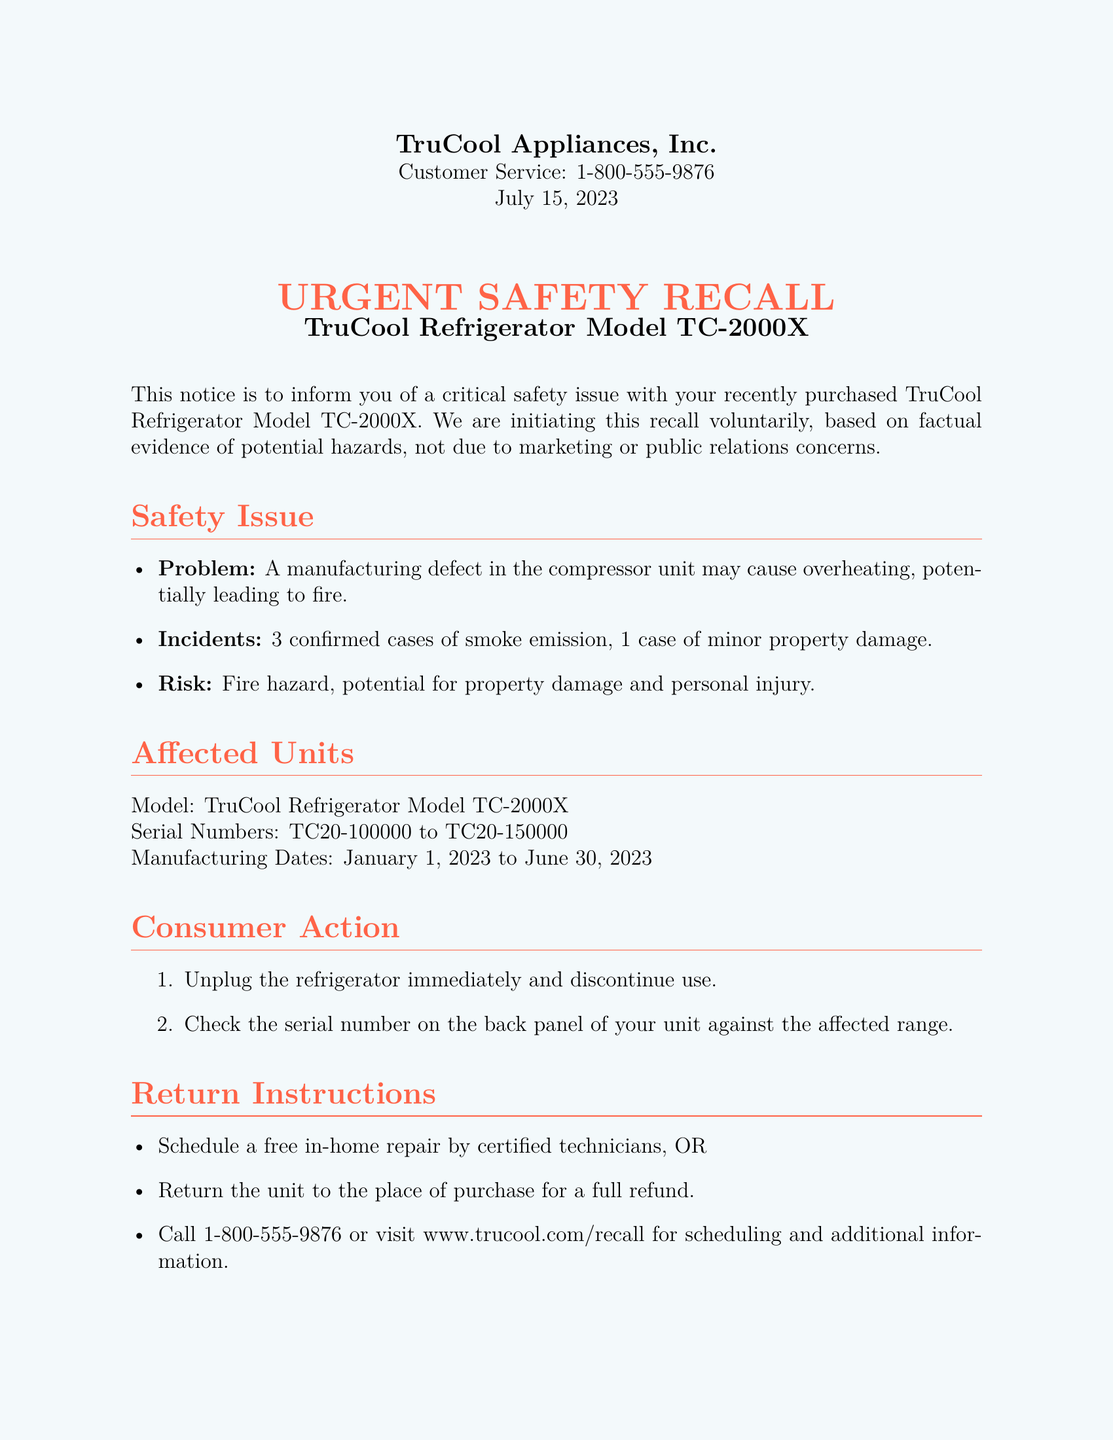What is the model of the refrigerator? The model of the refrigerator mentioned in the document is specified in the title and the affected units section.
Answer: TC-2000X What is the manufacturing date range for the affected units? The manufacturing dates for the affected units are detailed in the affected units section of the document.
Answer: January 1, 2023 to June 30, 2023 How many confirmed cases of smoke emission were reported? The number of confirmed smoke emission cases is stated under the incidents in the safety issue section.
Answer: 3 What is the compensation for inconvenience? The document lists the compensation for affected customers in the compensation section.
Answer: $50 gift card What should customers do with their refrigerator? The consumer action section provides instructions on what to do with the refrigerator.
Answer: Unplug the refrigerator immediately What is the phone number for customer service? The customer service contact information is provided at the beginning of the document.
Answer: 1-800-555-9876 What type of repairs are offered? The return instructions section explains the type of service available for customers.
Answer: Free in-home repair What is not required for a full refund? The document mentions a specific requirement regarding receipts in the compensation section.
Answer: No receipt required 